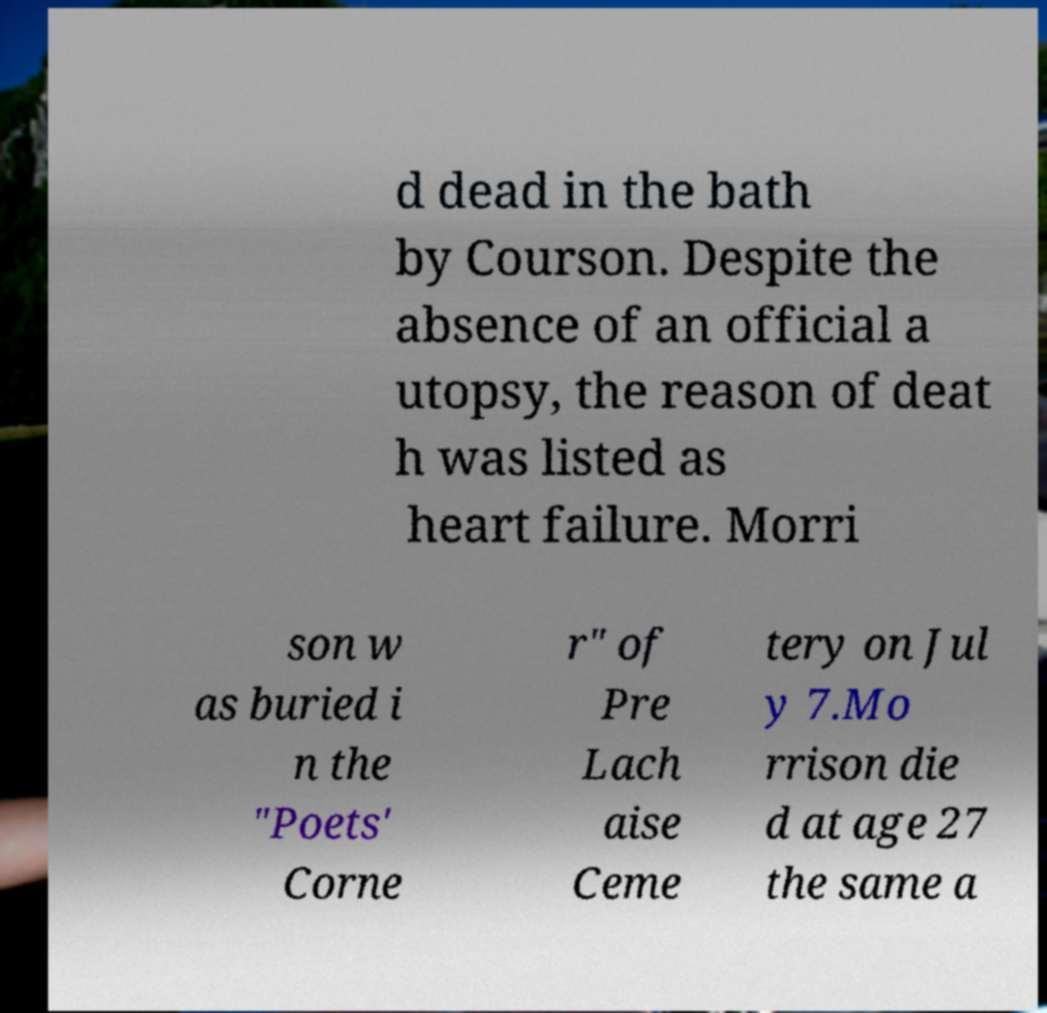I need the written content from this picture converted into text. Can you do that? d dead in the bath by Courson. Despite the absence of an official a utopsy, the reason of deat h was listed as heart failure. Morri son w as buried i n the "Poets' Corne r" of Pre Lach aise Ceme tery on Jul y 7.Mo rrison die d at age 27 the same a 